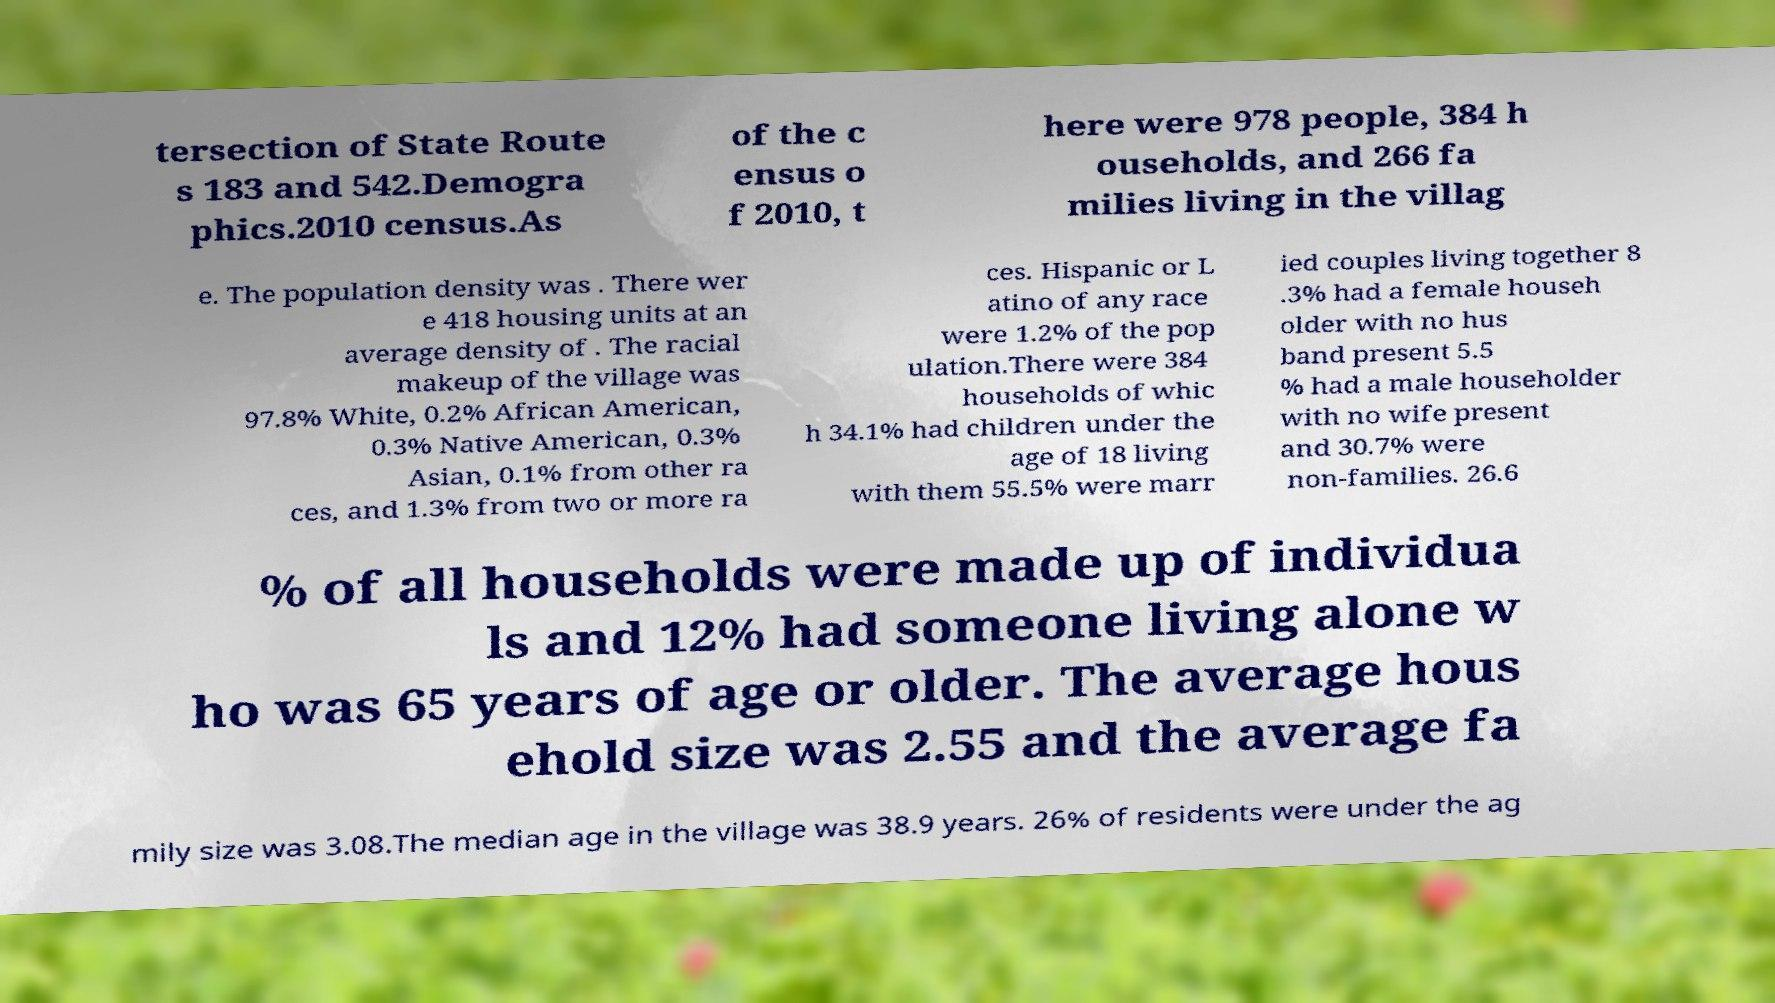Could you extract and type out the text from this image? tersection of State Route s 183 and 542.Demogra phics.2010 census.As of the c ensus o f 2010, t here were 978 people, 384 h ouseholds, and 266 fa milies living in the villag e. The population density was . There wer e 418 housing units at an average density of . The racial makeup of the village was 97.8% White, 0.2% African American, 0.3% Native American, 0.3% Asian, 0.1% from other ra ces, and 1.3% from two or more ra ces. Hispanic or L atino of any race were 1.2% of the pop ulation.There were 384 households of whic h 34.1% had children under the age of 18 living with them 55.5% were marr ied couples living together 8 .3% had a female househ older with no hus band present 5.5 % had a male householder with no wife present and 30.7% were non-families. 26.6 % of all households were made up of individua ls and 12% had someone living alone w ho was 65 years of age or older. The average hous ehold size was 2.55 and the average fa mily size was 3.08.The median age in the village was 38.9 years. 26% of residents were under the ag 